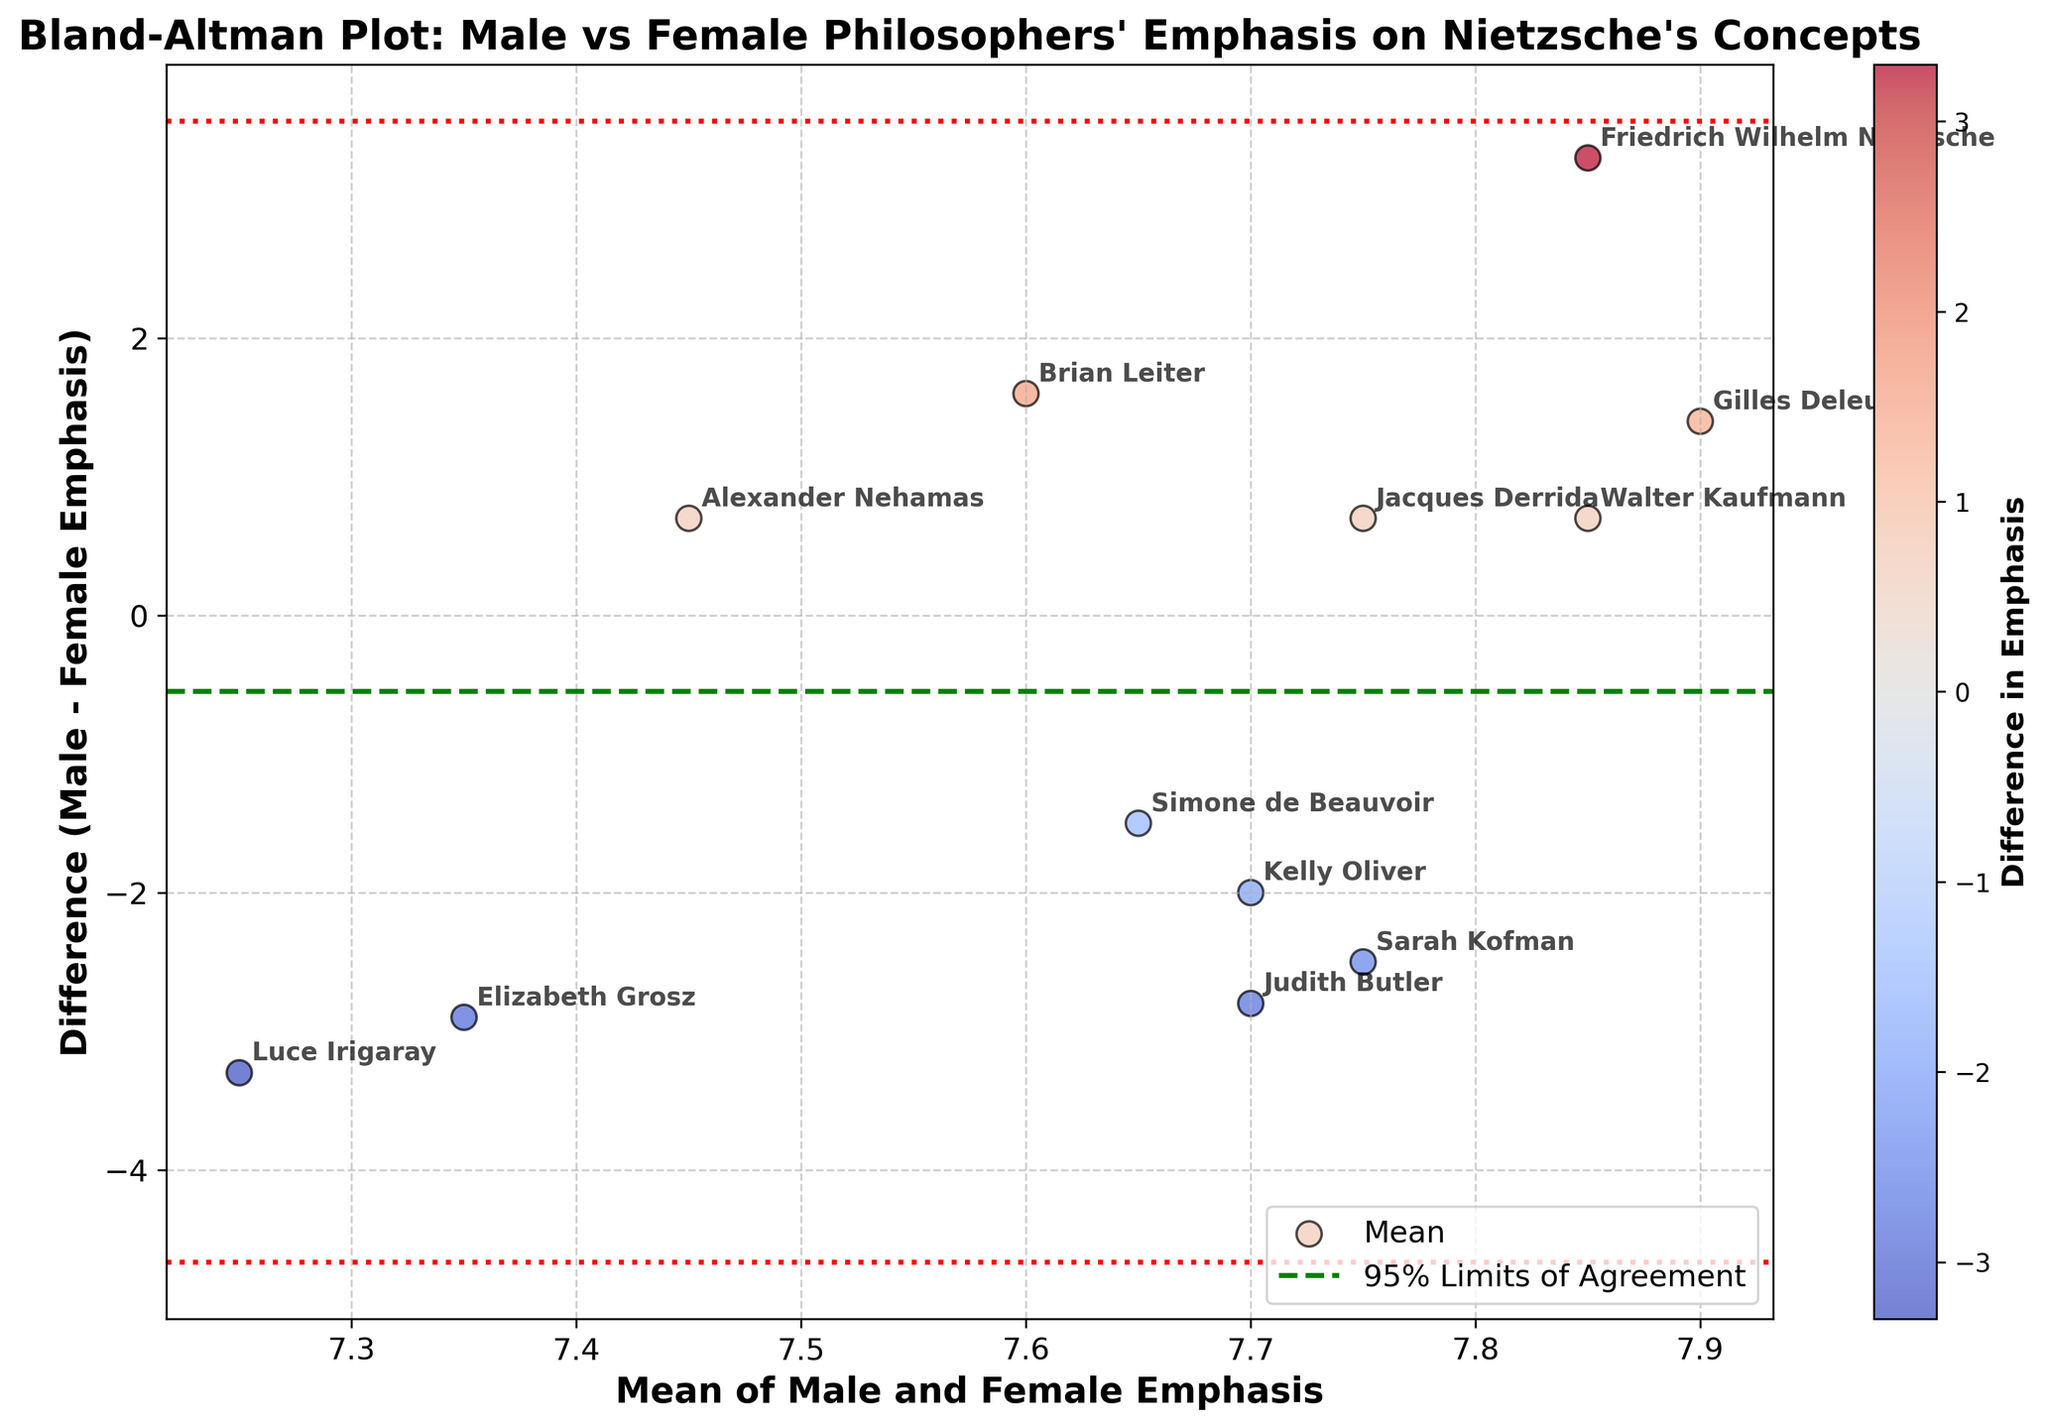What's the title of the plot? The title is located at the top of the figure, providing an overview of what the plot is about. In this case, it reads "Bland-Altman Plot: Male vs Female Philosophers' Emphasis on Nietzsche's Concepts".
Answer: Bland-Altman Plot: Male vs Female Philosophers' Emphasis on Nietzsche's Concepts How many philosophers are represented in the plot? Each philosopher is an annotated point on the plot. By counting all the annotations, we can determine the total number of philosophers. There are 12 annotations visible on the plot.
Answer: 12 What do the horizontal dashed and dotted lines represent? The upper and lower dotted lines represent the 95% limits of agreement, calculated as the mean difference plus or minus 1.96 times the standard deviation of the differences. The middle dashed line represents the mean difference.
Answer: Mean difference and 95% limits of agreement What's the mean of the differences between male and female emphasis? This is represented by the green dashed line on the plot, which indicates the mean of the differences between male and female emphasis.
Answer: The green dashed line Which philosopher has the largest positive difference in emphasis? By looking at the highest value point on the y-axis, Friedrich Wilhelm Nietzsche has the largest positive difference because his point is at the topmost position above the mean line.
Answer: Friedrich Wilhelm Nietzsche What is the range of the mean values of male and female emphasis? The x-axis represents the mean of male and female emphasis. The minimum and maximum values on this axis indicate the range. From the annotations, the means range approximately between 5.8 and 8.6.
Answer: Approximately 5.8 to 8.6 How many entries show a higher emphasis in female interpretations compared to male? Points below the horizontal dashed line (mean difference) indicate a higher emphasis by female philosophers. By counting these points, we get the number of entries. There are 6 points below the mean line.
Answer: 6 For which philosopher(s) is the difference in emphasis exactly equal (i.e., zero)? We need to look for points on the x-axis where the difference (y-axis) is zero. None of the points lie on the x-axis, hence no philosopher has a zero difference.
Answer: None Which philosophers have a difference in emphasis close to 1.5? We look for points on the plot around the y-values of 1.5 and -1.5. Brian Leiter has a difference of 1.6, close to 1.5, and Simone de Beauvoir has a difference of -1.5.
Answer: Brian Leiter and Simone de Beauvoir What is the significance of the color gradient in the scatter plot? The color gradient represents the magnitude of the difference in emphasis, with varying colors signifying different values of difference. The color bar indicates this information, directly correlating the color with the numerical difference.
Answer: Magnitude of the difference 